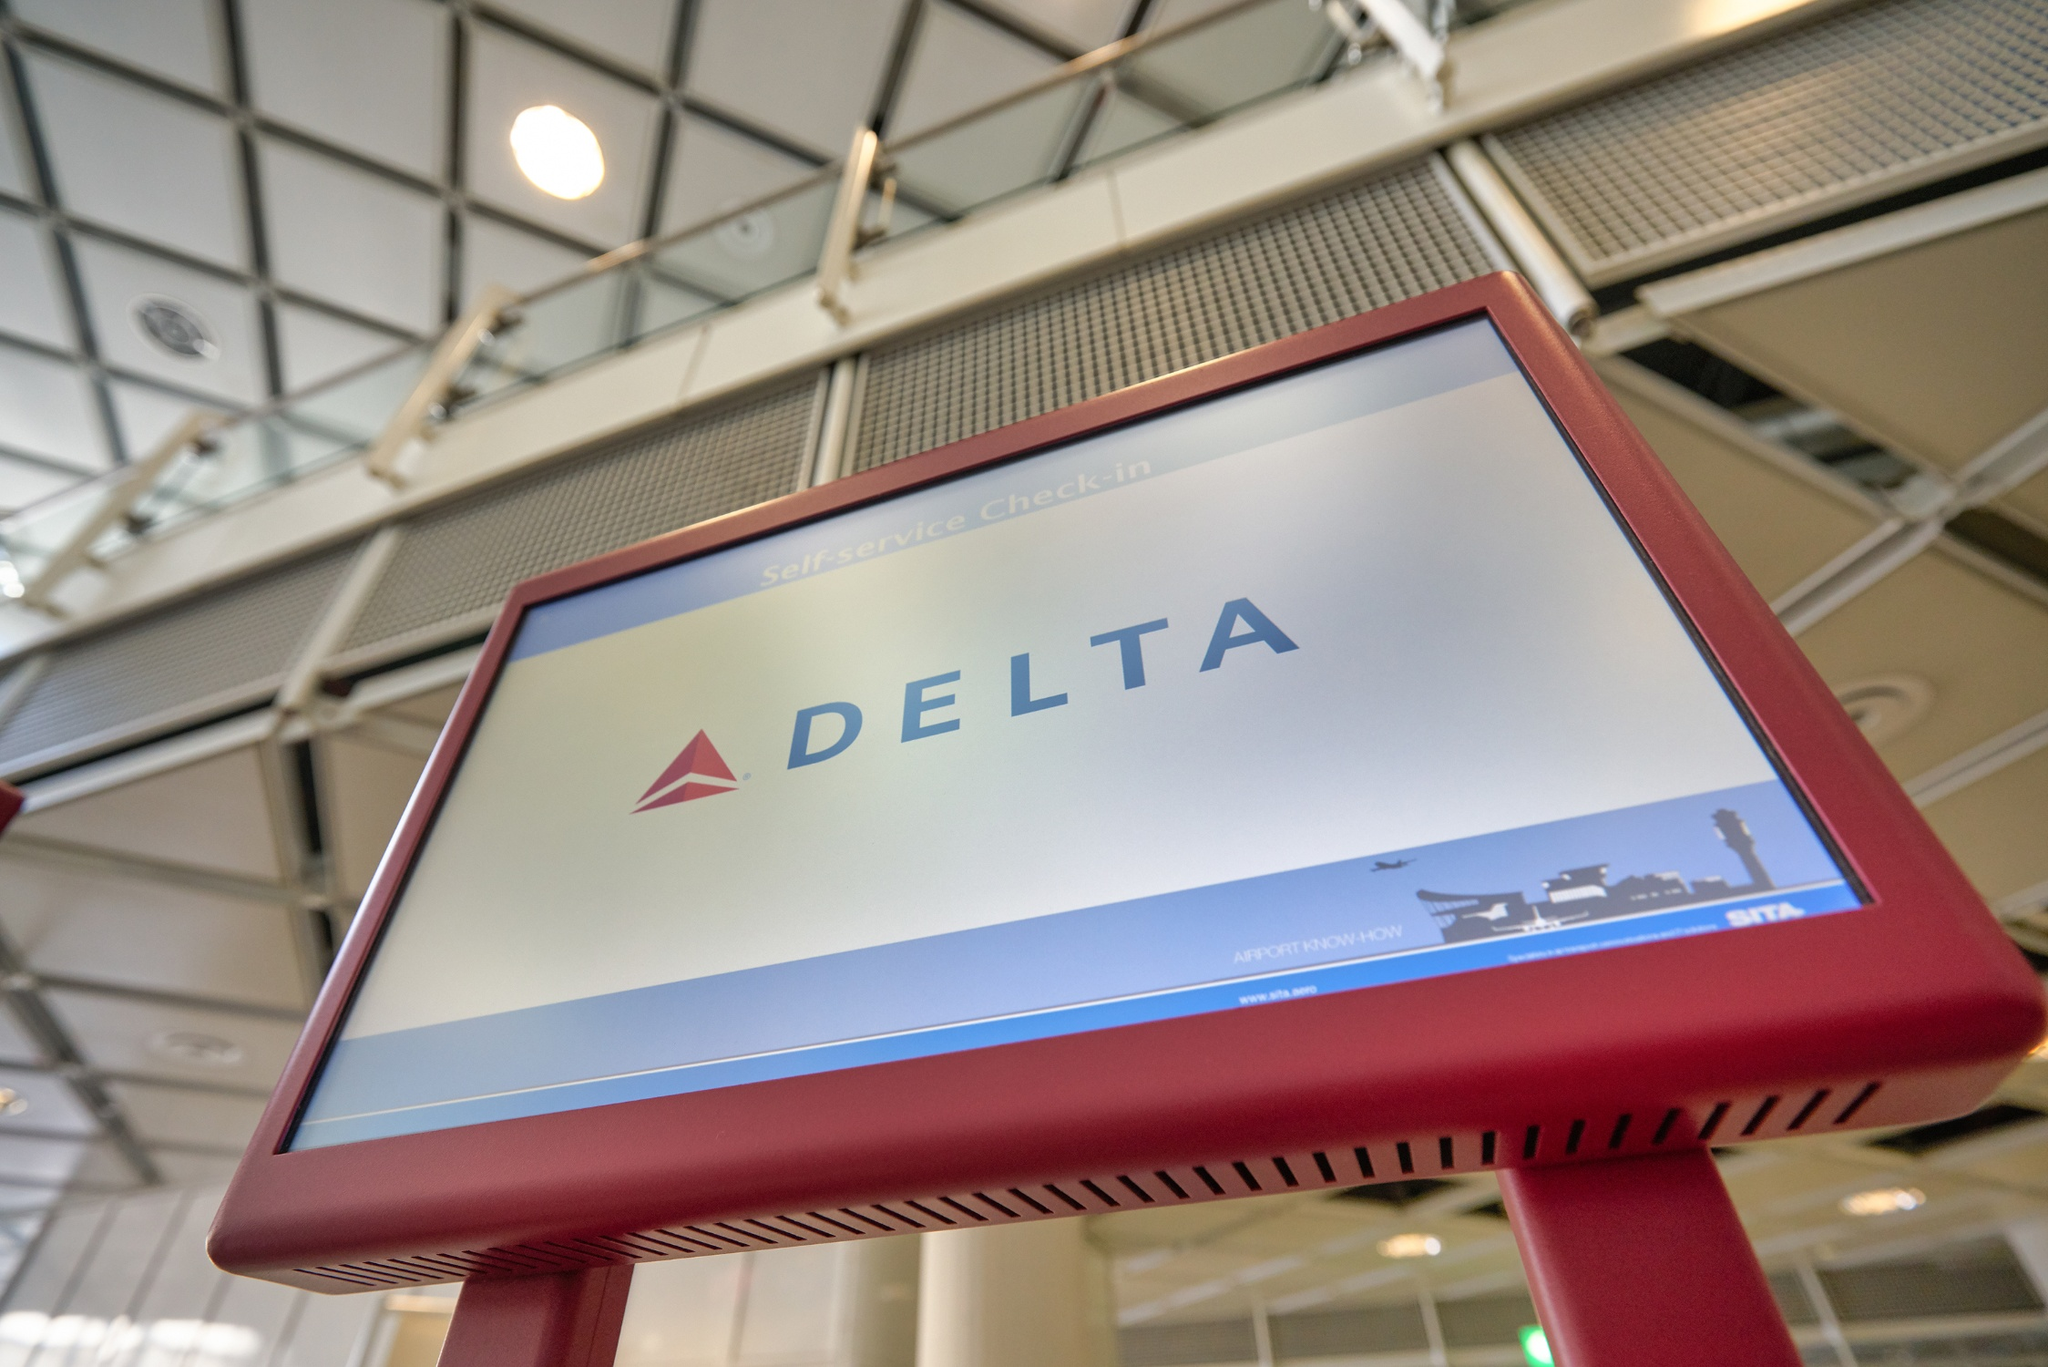Is there a future scenario where the kiosk could evolve further? Imagine a futuristic self-service check-in. In a future scenario, the self-service check-in kiosks could evolve to include advanced AI-driven assistance, providing a completely touchless experience. Travelers could simply approach the kiosk, and facial recognition technology would instantly verify their identity and retrieve their booking information. Holographic displays could give personalized greetings and instructions, guiding them through the check-in process. Furthermore, these kiosks could integrate with other airport systems, offering real-time updates on security wait times, gate changes, and even suggesting routes through the airport to avoid congestion. For those with language barriers, on-the-fly translation technology could ensure smooth communication. The kiosks of the future could become more than just a check-in point; they could be a comprehensive travel assistant providing end-to-end guidance and support. 